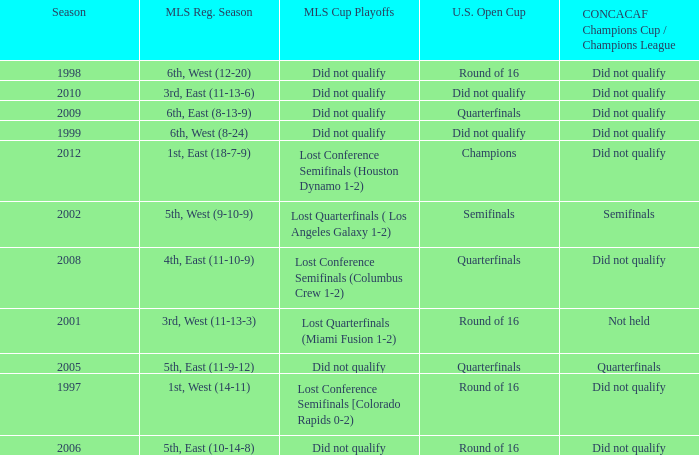How did the team place when they did not qualify for the Concaf Champions Cup but made it to Round of 16 in the U.S. Open Cup? Lost Conference Semifinals [Colorado Rapids 0-2), Did not qualify, Did not qualify. 